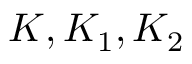Convert formula to latex. <formula><loc_0><loc_0><loc_500><loc_500>K , K _ { 1 } , K _ { 2 }</formula> 